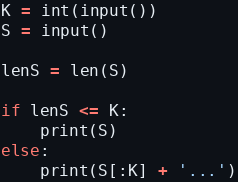Convert code to text. <code><loc_0><loc_0><loc_500><loc_500><_Python_>K = int(input())
S = input()

lenS = len(S)

if lenS <= K:
    print(S)
else:
    print(S[:K] + '...')
</code> 